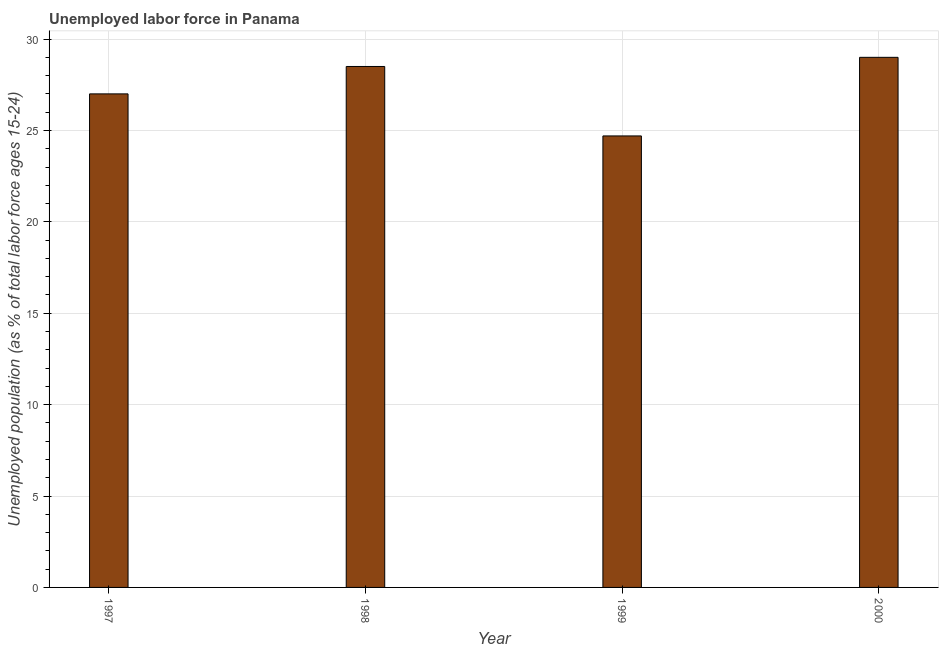Does the graph contain any zero values?
Make the answer very short. No. Does the graph contain grids?
Offer a terse response. Yes. What is the title of the graph?
Your response must be concise. Unemployed labor force in Panama. What is the label or title of the Y-axis?
Offer a very short reply. Unemployed population (as % of total labor force ages 15-24). Across all years, what is the maximum total unemployed youth population?
Your response must be concise. 29. Across all years, what is the minimum total unemployed youth population?
Offer a terse response. 24.7. In which year was the total unemployed youth population maximum?
Keep it short and to the point. 2000. What is the sum of the total unemployed youth population?
Give a very brief answer. 109.2. What is the average total unemployed youth population per year?
Keep it short and to the point. 27.3. What is the median total unemployed youth population?
Your answer should be very brief. 27.75. In how many years, is the total unemployed youth population greater than 29 %?
Offer a terse response. 0. What is the ratio of the total unemployed youth population in 1997 to that in 1999?
Ensure brevity in your answer.  1.09. Is the total unemployed youth population in 1997 less than that in 1998?
Provide a succinct answer. Yes. Is the sum of the total unemployed youth population in 1997 and 2000 greater than the maximum total unemployed youth population across all years?
Your answer should be compact. Yes. In how many years, is the total unemployed youth population greater than the average total unemployed youth population taken over all years?
Ensure brevity in your answer.  2. What is the difference between two consecutive major ticks on the Y-axis?
Your answer should be very brief. 5. What is the Unemployed population (as % of total labor force ages 15-24) in 1997?
Ensure brevity in your answer.  27. What is the Unemployed population (as % of total labor force ages 15-24) in 1999?
Your response must be concise. 24.7. What is the difference between the Unemployed population (as % of total labor force ages 15-24) in 1997 and 2000?
Offer a very short reply. -2. What is the difference between the Unemployed population (as % of total labor force ages 15-24) in 1998 and 1999?
Offer a terse response. 3.8. What is the difference between the Unemployed population (as % of total labor force ages 15-24) in 1999 and 2000?
Provide a short and direct response. -4.3. What is the ratio of the Unemployed population (as % of total labor force ages 15-24) in 1997 to that in 1998?
Provide a short and direct response. 0.95. What is the ratio of the Unemployed population (as % of total labor force ages 15-24) in 1997 to that in 1999?
Your response must be concise. 1.09. What is the ratio of the Unemployed population (as % of total labor force ages 15-24) in 1998 to that in 1999?
Your answer should be very brief. 1.15. What is the ratio of the Unemployed population (as % of total labor force ages 15-24) in 1998 to that in 2000?
Your answer should be very brief. 0.98. What is the ratio of the Unemployed population (as % of total labor force ages 15-24) in 1999 to that in 2000?
Give a very brief answer. 0.85. 